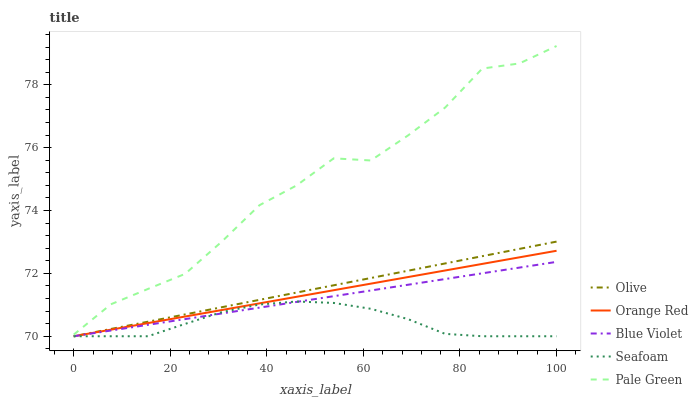Does Seafoam have the minimum area under the curve?
Answer yes or no. Yes. Does Pale Green have the maximum area under the curve?
Answer yes or no. Yes. Does Orange Red have the minimum area under the curve?
Answer yes or no. No. Does Orange Red have the maximum area under the curve?
Answer yes or no. No. Is Orange Red the smoothest?
Answer yes or no. Yes. Is Pale Green the roughest?
Answer yes or no. Yes. Is Pale Green the smoothest?
Answer yes or no. No. Is Orange Red the roughest?
Answer yes or no. No. Does Olive have the lowest value?
Answer yes or no. Yes. Does Pale Green have the lowest value?
Answer yes or no. No. Does Pale Green have the highest value?
Answer yes or no. Yes. Does Orange Red have the highest value?
Answer yes or no. No. Is Orange Red less than Pale Green?
Answer yes or no. Yes. Is Pale Green greater than Orange Red?
Answer yes or no. Yes. Does Blue Violet intersect Olive?
Answer yes or no. Yes. Is Blue Violet less than Olive?
Answer yes or no. No. Is Blue Violet greater than Olive?
Answer yes or no. No. Does Orange Red intersect Pale Green?
Answer yes or no. No. 